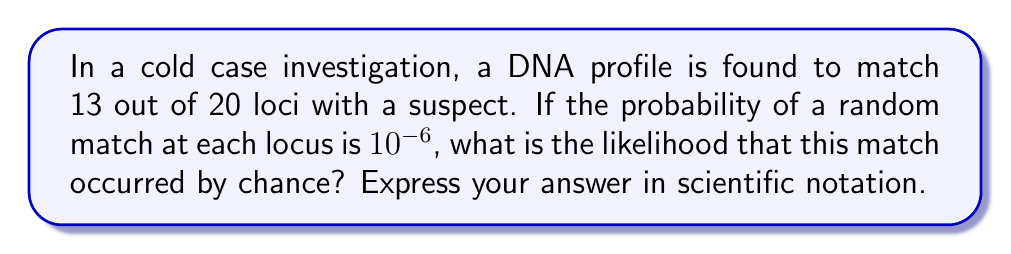Could you help me with this problem? Let's approach this step-by-step:

1) First, we need to calculate the probability of matching at 13 specific loci and not matching at 7 specific loci. This is given by:

   $$(10^{-6})^{13} \cdot (1-10^{-6})^7$$

2) However, the 13 matching loci could be any 13 out of the 20. We need to account for all possible combinations. This is given by the binomial coefficient:

   $$\binom{20}{13} = \frac{20!}{13!(20-13)!} = \frac{20!}{13!7!}$$

3) The total probability is the product of these:

   $$P = \binom{20}{13} \cdot (10^{-6})^{13} \cdot (1-10^{-6})^7$$

4) Let's calculate each part:
   
   $\binom{20}{13} = 77,520$
   
   $(10^{-6})^{13} = 10^{-78}$
   
   $(1-10^{-6})^7 \approx 1$ (since $10^{-6}$ is very small)

5) Multiplying these together:

   $$P = 77,520 \cdot 10^{-78} \cdot 1 = 7.752 \times 10^{-74}$$
Answer: $7.752 \times 10^{-74}$ 